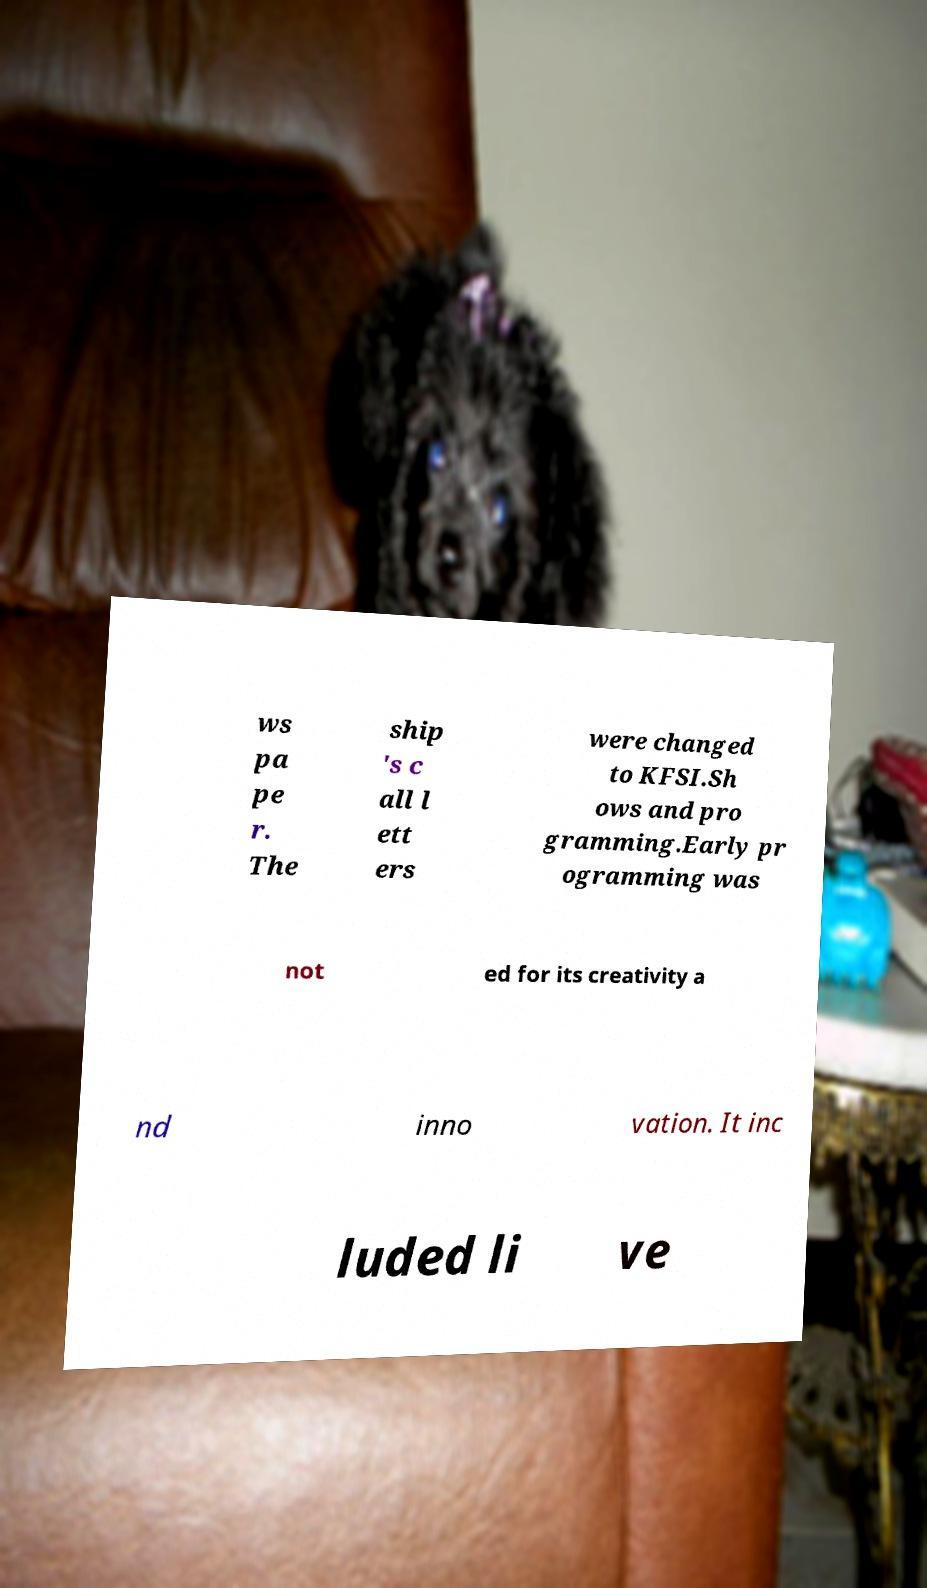There's text embedded in this image that I need extracted. Can you transcribe it verbatim? ws pa pe r. The ship 's c all l ett ers were changed to KFSI.Sh ows and pro gramming.Early pr ogramming was not ed for its creativity a nd inno vation. It inc luded li ve 